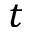Convert formula to latex. <formula><loc_0><loc_0><loc_500><loc_500>t</formula> 